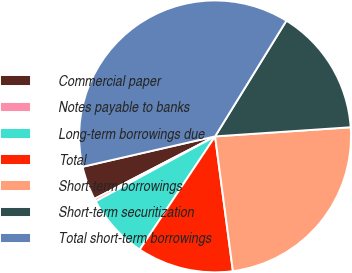Convert chart to OTSL. <chart><loc_0><loc_0><loc_500><loc_500><pie_chart><fcel>Commercial paper<fcel>Notes payable to banks<fcel>Long-term borrowings due<fcel>Total<fcel>Short-term borrowings<fcel>Short-term securitization<fcel>Total short-term borrowings<nl><fcel>4.02%<fcel>0.32%<fcel>7.73%<fcel>11.44%<fcel>23.98%<fcel>15.14%<fcel>37.38%<nl></chart> 